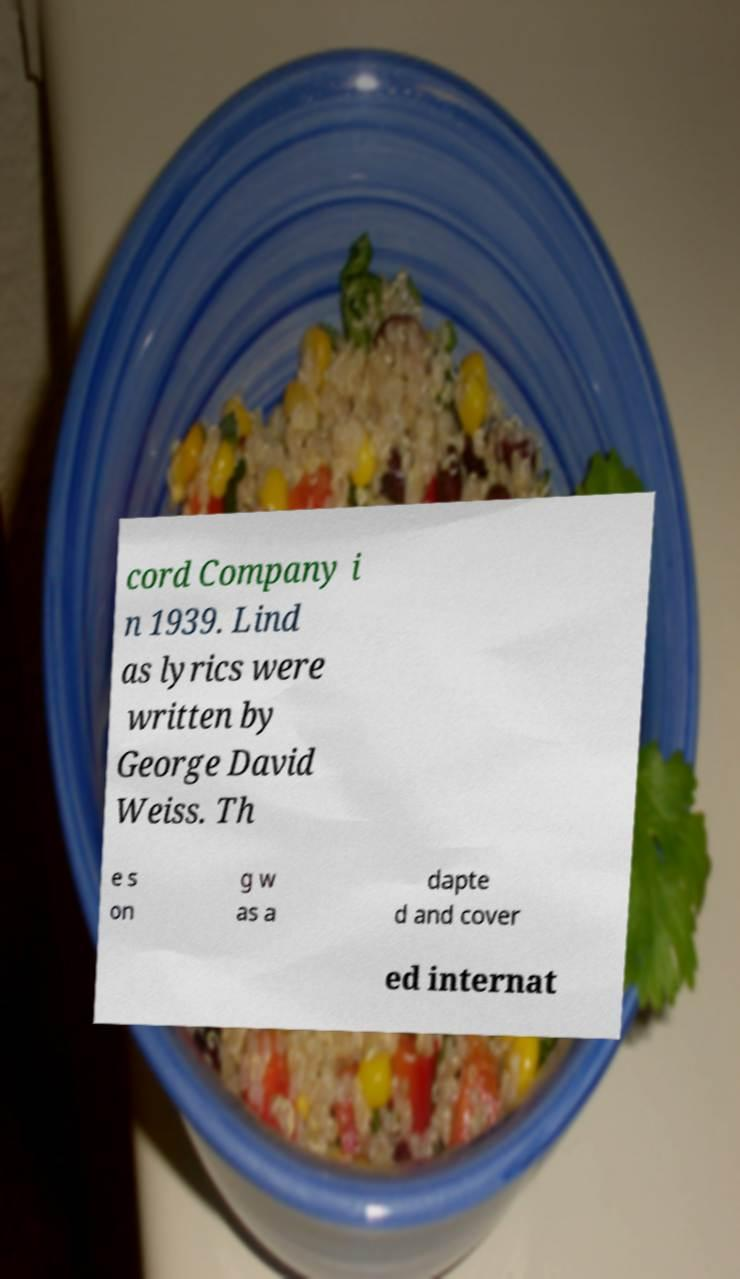Can you accurately transcribe the text from the provided image for me? cord Company i n 1939. Lind as lyrics were written by George David Weiss. Th e s on g w as a dapte d and cover ed internat 